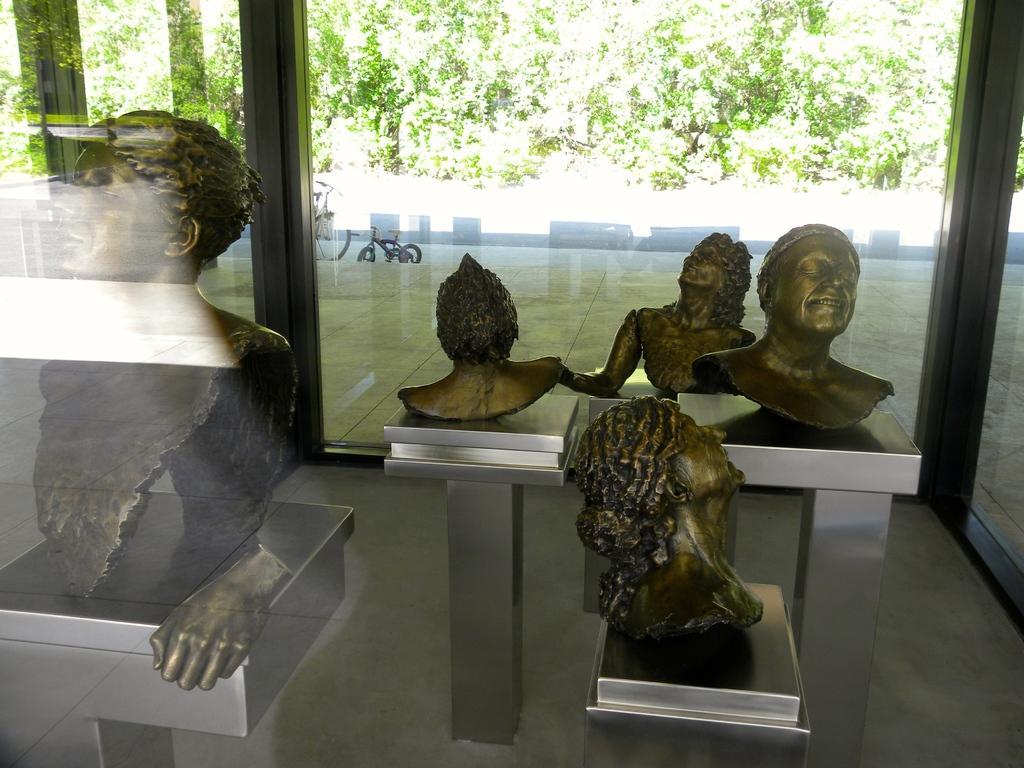Please provide a concise description of this image. Some artifacts are showcased in a glass enclosure. They depict humans. There are two bicycles and some trees in the background. 